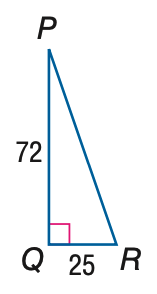Question: Find the measure of \angle R to the nearest tenth.
Choices:
A. 19.1
B. 20.3
C. 69.7
D. 70.9
Answer with the letter. Answer: D 